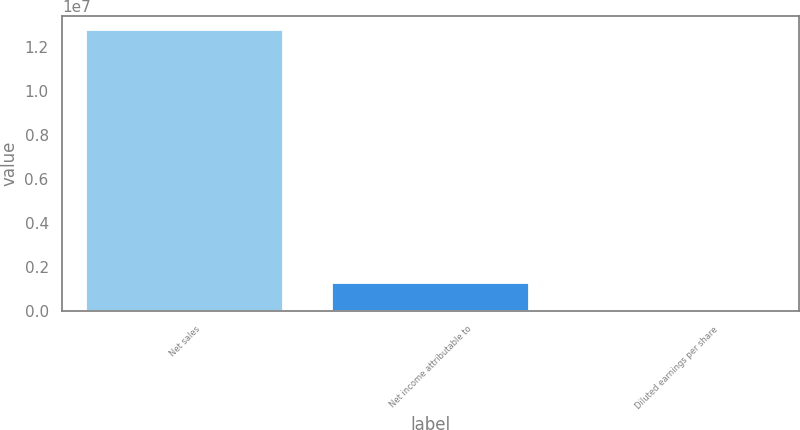Convert chart. <chart><loc_0><loc_0><loc_500><loc_500><bar_chart><fcel>Net sales<fcel>Net income attributable to<fcel>Diluted earnings per share<nl><fcel>1.27721e+07<fcel>1.27721e+06<fcel>5.47<nl></chart> 